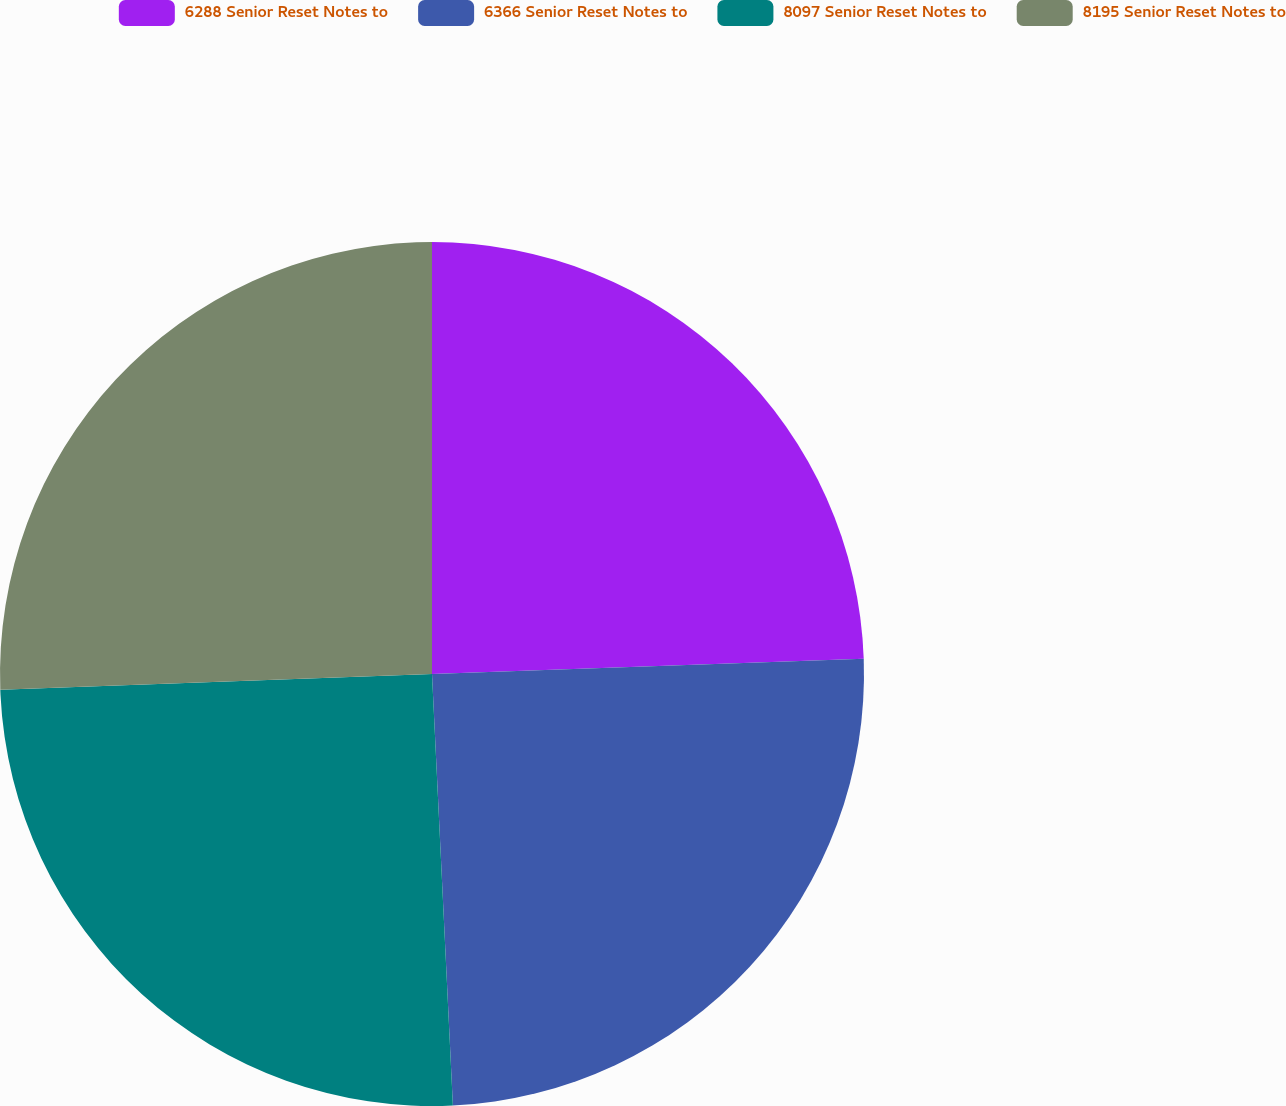Convert chart to OTSL. <chart><loc_0><loc_0><loc_500><loc_500><pie_chart><fcel>6288 Senior Reset Notes to<fcel>6366 Senior Reset Notes to<fcel>8097 Senior Reset Notes to<fcel>8195 Senior Reset Notes to<nl><fcel>24.44%<fcel>24.79%<fcel>25.19%<fcel>25.58%<nl></chart> 